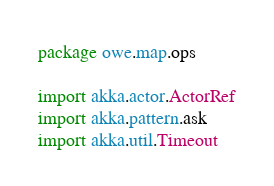<code> <loc_0><loc_0><loc_500><loc_500><_Scala_>package owe.map.ops

import akka.actor.ActorRef
import akka.pattern.ask
import akka.util.Timeout</code> 